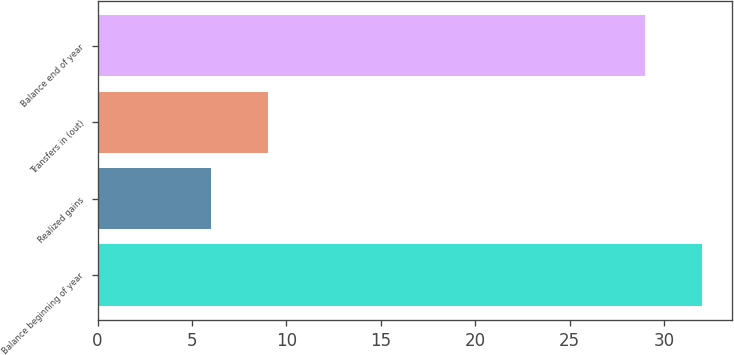Convert chart to OTSL. <chart><loc_0><loc_0><loc_500><loc_500><bar_chart><fcel>Balance beginning of year<fcel>Realized gains<fcel>Transfers in (out)<fcel>Balance end of year<nl><fcel>32<fcel>6<fcel>9<fcel>29<nl></chart> 